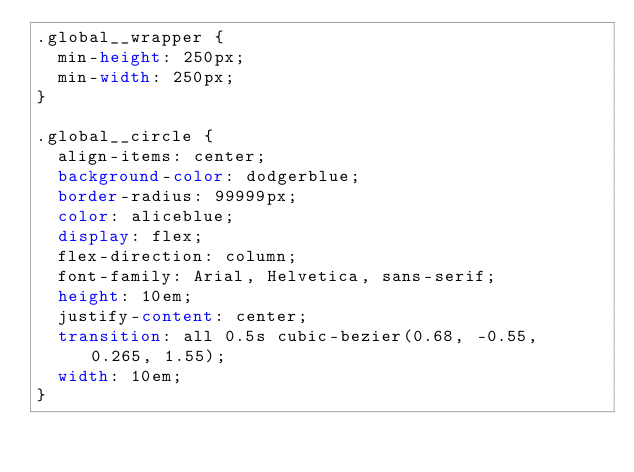<code> <loc_0><loc_0><loc_500><loc_500><_CSS_>.global__wrapper {
  min-height: 250px;
  min-width: 250px;
}

.global__circle {
  align-items: center;
  background-color: dodgerblue;
  border-radius: 99999px;
  color: aliceblue;
  display: flex;
  flex-direction: column;
  font-family: Arial, Helvetica, sans-serif;
  height: 10em;
  justify-content: center;
  transition: all 0.5s cubic-bezier(0.68, -0.55, 0.265, 1.55);
  width: 10em;
}
</code> 